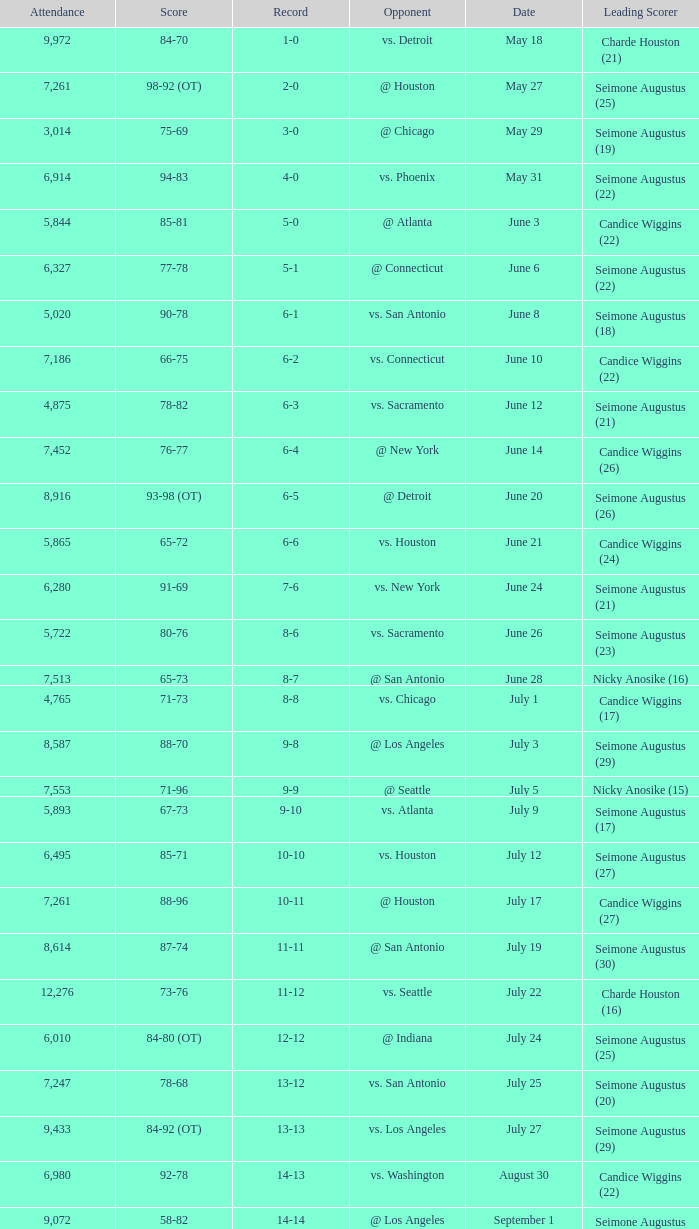Which Leading Scorer has an Opponent of @ seattle, and a Record of 14-16? Seimone Augustus (26). 